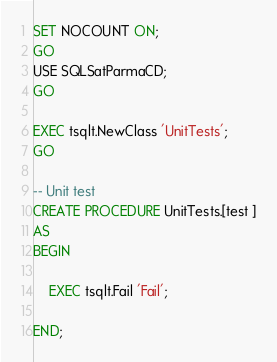<code> <loc_0><loc_0><loc_500><loc_500><_SQL_>SET NOCOUNT ON;
GO
USE SQLSatParmaCD;
GO

EXEC tsqlt.NewClass 'UnitTests';
GO

-- Unit test
CREATE PROCEDURE UnitTests.[test ]
AS
BEGIN

    EXEC tsqlt.Fail 'Fail';

END;</code> 